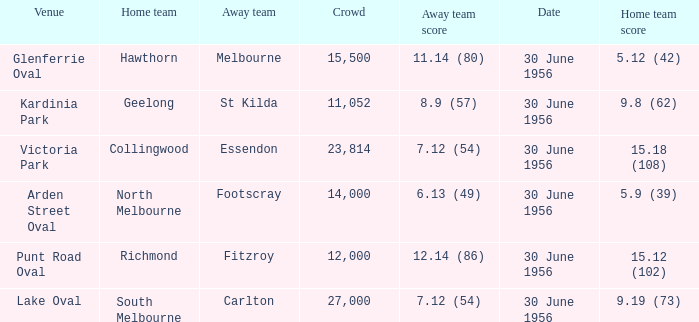What away team has a home team score of 15.18 (108)? Essendon. Can you give me this table as a dict? {'header': ['Venue', 'Home team', 'Away team', 'Crowd', 'Away team score', 'Date', 'Home team score'], 'rows': [['Glenferrie Oval', 'Hawthorn', 'Melbourne', '15,500', '11.14 (80)', '30 June 1956', '5.12 (42)'], ['Kardinia Park', 'Geelong', 'St Kilda', '11,052', '8.9 (57)', '30 June 1956', '9.8 (62)'], ['Victoria Park', 'Collingwood', 'Essendon', '23,814', '7.12 (54)', '30 June 1956', '15.18 (108)'], ['Arden Street Oval', 'North Melbourne', 'Footscray', '14,000', '6.13 (49)', '30 June 1956', '5.9 (39)'], ['Punt Road Oval', 'Richmond', 'Fitzroy', '12,000', '12.14 (86)', '30 June 1956', '15.12 (102)'], ['Lake Oval', 'South Melbourne', 'Carlton', '27,000', '7.12 (54)', '30 June 1956', '9.19 (73)']]} 